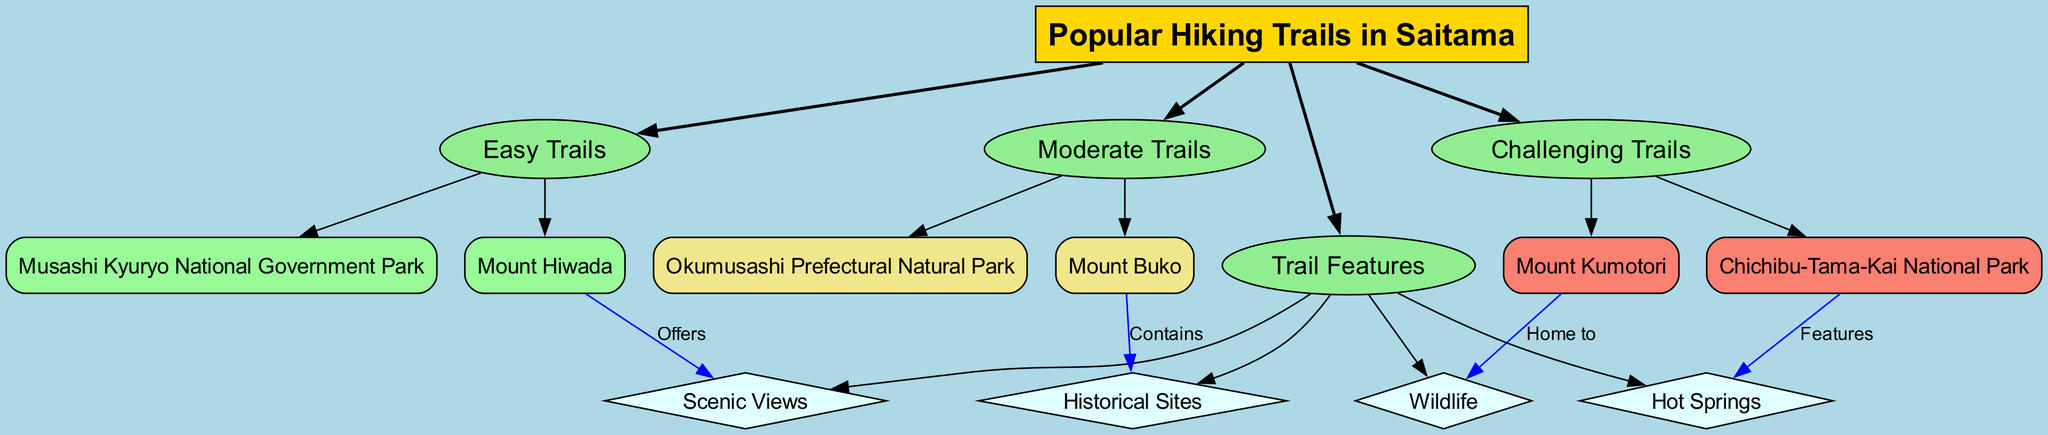What are two easy hiking trails in Saitama? The diagram lists "Mount Hiwada" and "Musashi Kyuryo National Government Park" under the category of Easy Trails.
Answer: Mount Hiwada, Musashi Kyuryo National Government Park Which trail is home to wildlife? "Mount Kumotori" has the connection labeled "Home to" for the feature "Wildlife", indicating that this trail is known for its wildlife.
Answer: Mount Kumotori How many moderate hiking trails are there? The diagram indicates two trails under the Moderate Trails category: "Mount Buko" and "Okumusashi Prefectural Natural Park". Therefore, the count is 2.
Answer: 2 What feature is associated with Chichibu-Tama-Kai National Park? The diagram shows that Chichibu-Tama-Kai National Park has a connection labeled "Features" with the feature "Hot Springs".
Answer: Hot Springs Which easy trail offers scenic views? The diagram establishes a connection stating that "Mount Hiwada" offers "Scenic Views", meaning it is associated with this feature.
Answer: Mount Hiwada What type of trail is Mount Buko? Mount Buko is listed under the Moderate Trails category, indicating it has a moderate difficulty level.
Answer: Moderate What is the relationship between historical sites and Mount Buko? The diagram links "Mount Buko" with the label "Contains" to "Historical Sites", showing that this trail includes sites of historical significance.
Answer: Contains Which category has the most trails listed? The diagram does not list the exact number of trails per category, but given that Easy, Moderate, and Challenging categories have fewer than three listed trails each, there is no explicit category that stands out by having the most trails. Therefore, they are all equal in quantity.
Answer: Equal What type of connection does "Mount Kumotori" have regarding wildlife? The connection is labeled as "Home to", indicating that this connection specifically denotes that "Mount Kumotori" is a habitat or haven for wildlife.
Answer: Home to 